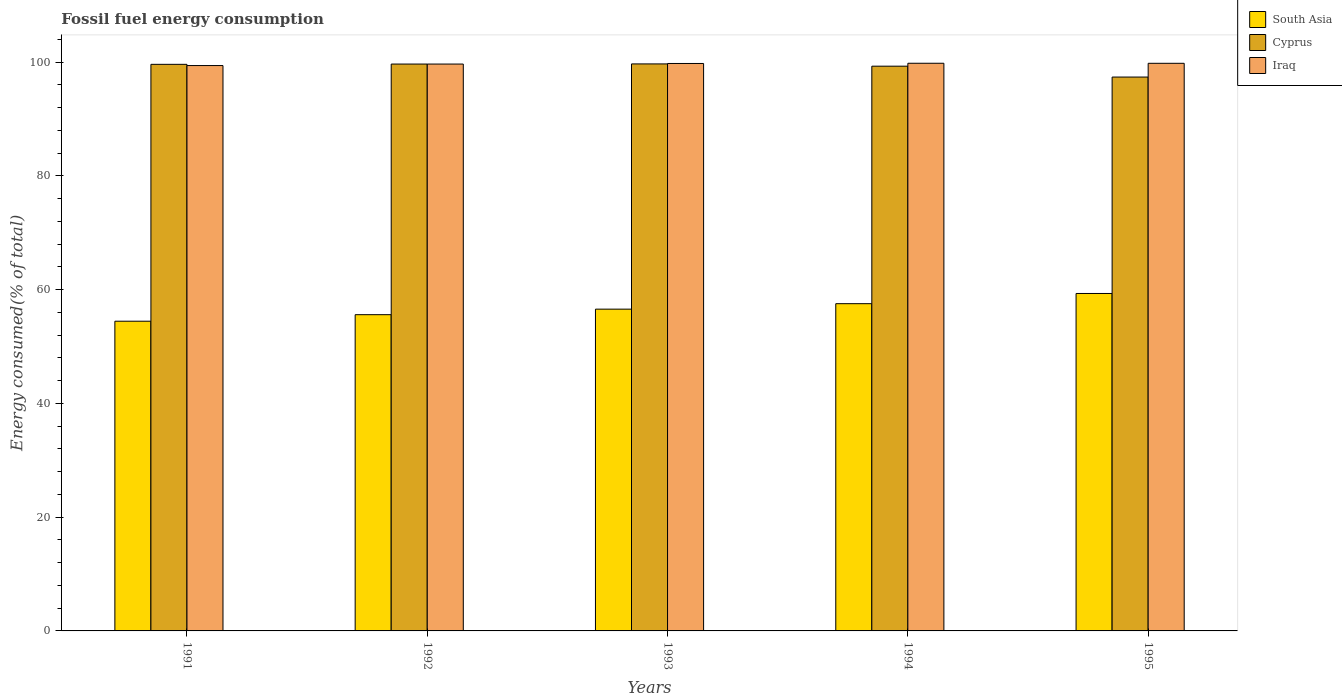How many different coloured bars are there?
Offer a terse response. 3. How many bars are there on the 2nd tick from the left?
Your response must be concise. 3. How many bars are there on the 5th tick from the right?
Offer a very short reply. 3. What is the label of the 5th group of bars from the left?
Provide a succinct answer. 1995. What is the percentage of energy consumed in Cyprus in 1994?
Give a very brief answer. 99.28. Across all years, what is the maximum percentage of energy consumed in Iraq?
Your answer should be compact. 99.79. Across all years, what is the minimum percentage of energy consumed in Iraq?
Give a very brief answer. 99.39. In which year was the percentage of energy consumed in Iraq maximum?
Give a very brief answer. 1994. In which year was the percentage of energy consumed in South Asia minimum?
Provide a succinct answer. 1991. What is the total percentage of energy consumed in Iraq in the graph?
Keep it short and to the point. 498.36. What is the difference between the percentage of energy consumed in Cyprus in 1991 and that in 1995?
Offer a very short reply. 2.24. What is the difference between the percentage of energy consumed in Cyprus in 1991 and the percentage of energy consumed in South Asia in 1994?
Ensure brevity in your answer.  42.08. What is the average percentage of energy consumed in South Asia per year?
Keep it short and to the point. 56.69. In the year 1994, what is the difference between the percentage of energy consumed in Iraq and percentage of energy consumed in South Asia?
Offer a terse response. 42.26. What is the ratio of the percentage of energy consumed in South Asia in 1992 to that in 1993?
Keep it short and to the point. 0.98. Is the difference between the percentage of energy consumed in Iraq in 1994 and 1995 greater than the difference between the percentage of energy consumed in South Asia in 1994 and 1995?
Ensure brevity in your answer.  Yes. What is the difference between the highest and the second highest percentage of energy consumed in South Asia?
Offer a terse response. 1.79. What is the difference between the highest and the lowest percentage of energy consumed in South Asia?
Give a very brief answer. 4.88. Is the sum of the percentage of energy consumed in Cyprus in 1993 and 1994 greater than the maximum percentage of energy consumed in Iraq across all years?
Offer a terse response. Yes. What does the 3rd bar from the left in 1991 represents?
Give a very brief answer. Iraq. What does the 2nd bar from the right in 1993 represents?
Ensure brevity in your answer.  Cyprus. How many bars are there?
Offer a very short reply. 15. What is the difference between two consecutive major ticks on the Y-axis?
Keep it short and to the point. 20. Are the values on the major ticks of Y-axis written in scientific E-notation?
Offer a terse response. No. Does the graph contain any zero values?
Your answer should be compact. No. Where does the legend appear in the graph?
Offer a terse response. Top right. What is the title of the graph?
Ensure brevity in your answer.  Fossil fuel energy consumption. What is the label or title of the X-axis?
Give a very brief answer. Years. What is the label or title of the Y-axis?
Offer a terse response. Energy consumed(% of total). What is the Energy consumed(% of total) in South Asia in 1991?
Keep it short and to the point. 54.44. What is the Energy consumed(% of total) of Cyprus in 1991?
Ensure brevity in your answer.  99.6. What is the Energy consumed(% of total) in Iraq in 1991?
Give a very brief answer. 99.39. What is the Energy consumed(% of total) in South Asia in 1992?
Provide a short and direct response. 55.59. What is the Energy consumed(% of total) of Cyprus in 1992?
Keep it short and to the point. 99.65. What is the Energy consumed(% of total) of Iraq in 1992?
Your answer should be compact. 99.65. What is the Energy consumed(% of total) of South Asia in 1993?
Provide a succinct answer. 56.56. What is the Energy consumed(% of total) of Cyprus in 1993?
Offer a very short reply. 99.68. What is the Energy consumed(% of total) in Iraq in 1993?
Ensure brevity in your answer.  99.75. What is the Energy consumed(% of total) of South Asia in 1994?
Keep it short and to the point. 57.53. What is the Energy consumed(% of total) of Cyprus in 1994?
Your answer should be compact. 99.28. What is the Energy consumed(% of total) of Iraq in 1994?
Provide a succinct answer. 99.79. What is the Energy consumed(% of total) of South Asia in 1995?
Keep it short and to the point. 59.32. What is the Energy consumed(% of total) of Cyprus in 1995?
Provide a short and direct response. 97.37. What is the Energy consumed(% of total) in Iraq in 1995?
Offer a very short reply. 99.78. Across all years, what is the maximum Energy consumed(% of total) in South Asia?
Provide a short and direct response. 59.32. Across all years, what is the maximum Energy consumed(% of total) in Cyprus?
Your response must be concise. 99.68. Across all years, what is the maximum Energy consumed(% of total) in Iraq?
Your response must be concise. 99.79. Across all years, what is the minimum Energy consumed(% of total) of South Asia?
Provide a succinct answer. 54.44. Across all years, what is the minimum Energy consumed(% of total) of Cyprus?
Ensure brevity in your answer.  97.37. Across all years, what is the minimum Energy consumed(% of total) in Iraq?
Offer a very short reply. 99.39. What is the total Energy consumed(% of total) in South Asia in the graph?
Your answer should be compact. 283.45. What is the total Energy consumed(% of total) in Cyprus in the graph?
Keep it short and to the point. 495.57. What is the total Energy consumed(% of total) in Iraq in the graph?
Offer a very short reply. 498.36. What is the difference between the Energy consumed(% of total) in South Asia in 1991 and that in 1992?
Keep it short and to the point. -1.15. What is the difference between the Energy consumed(% of total) of Cyprus in 1991 and that in 1992?
Make the answer very short. -0.05. What is the difference between the Energy consumed(% of total) of Iraq in 1991 and that in 1992?
Offer a terse response. -0.26. What is the difference between the Energy consumed(% of total) of South Asia in 1991 and that in 1993?
Give a very brief answer. -2.12. What is the difference between the Energy consumed(% of total) in Cyprus in 1991 and that in 1993?
Offer a terse response. -0.07. What is the difference between the Energy consumed(% of total) in Iraq in 1991 and that in 1993?
Ensure brevity in your answer.  -0.37. What is the difference between the Energy consumed(% of total) in South Asia in 1991 and that in 1994?
Keep it short and to the point. -3.08. What is the difference between the Energy consumed(% of total) in Cyprus in 1991 and that in 1994?
Ensure brevity in your answer.  0.33. What is the difference between the Energy consumed(% of total) of Iraq in 1991 and that in 1994?
Make the answer very short. -0.4. What is the difference between the Energy consumed(% of total) of South Asia in 1991 and that in 1995?
Provide a succinct answer. -4.88. What is the difference between the Energy consumed(% of total) in Cyprus in 1991 and that in 1995?
Your response must be concise. 2.24. What is the difference between the Energy consumed(% of total) in Iraq in 1991 and that in 1995?
Offer a terse response. -0.39. What is the difference between the Energy consumed(% of total) in South Asia in 1992 and that in 1993?
Your answer should be very brief. -0.97. What is the difference between the Energy consumed(% of total) of Cyprus in 1992 and that in 1993?
Provide a succinct answer. -0.03. What is the difference between the Energy consumed(% of total) in Iraq in 1992 and that in 1993?
Ensure brevity in your answer.  -0.1. What is the difference between the Energy consumed(% of total) in South Asia in 1992 and that in 1994?
Provide a short and direct response. -1.93. What is the difference between the Energy consumed(% of total) of Cyprus in 1992 and that in 1994?
Your answer should be very brief. 0.37. What is the difference between the Energy consumed(% of total) of Iraq in 1992 and that in 1994?
Make the answer very short. -0.14. What is the difference between the Energy consumed(% of total) of South Asia in 1992 and that in 1995?
Provide a succinct answer. -3.73. What is the difference between the Energy consumed(% of total) in Cyprus in 1992 and that in 1995?
Offer a terse response. 2.28. What is the difference between the Energy consumed(% of total) in Iraq in 1992 and that in 1995?
Give a very brief answer. -0.13. What is the difference between the Energy consumed(% of total) in South Asia in 1993 and that in 1994?
Provide a succinct answer. -0.96. What is the difference between the Energy consumed(% of total) in Cyprus in 1993 and that in 1994?
Give a very brief answer. 0.4. What is the difference between the Energy consumed(% of total) in Iraq in 1993 and that in 1994?
Your answer should be very brief. -0.04. What is the difference between the Energy consumed(% of total) of South Asia in 1993 and that in 1995?
Provide a succinct answer. -2.76. What is the difference between the Energy consumed(% of total) in Cyprus in 1993 and that in 1995?
Offer a very short reply. 2.31. What is the difference between the Energy consumed(% of total) of Iraq in 1993 and that in 1995?
Provide a succinct answer. -0.03. What is the difference between the Energy consumed(% of total) in South Asia in 1994 and that in 1995?
Your response must be concise. -1.79. What is the difference between the Energy consumed(% of total) in Cyprus in 1994 and that in 1995?
Offer a very short reply. 1.91. What is the difference between the Energy consumed(% of total) of Iraq in 1994 and that in 1995?
Provide a succinct answer. 0.01. What is the difference between the Energy consumed(% of total) in South Asia in 1991 and the Energy consumed(% of total) in Cyprus in 1992?
Your answer should be compact. -45.21. What is the difference between the Energy consumed(% of total) of South Asia in 1991 and the Energy consumed(% of total) of Iraq in 1992?
Your answer should be very brief. -45.21. What is the difference between the Energy consumed(% of total) in Cyprus in 1991 and the Energy consumed(% of total) in Iraq in 1992?
Provide a short and direct response. -0.05. What is the difference between the Energy consumed(% of total) of South Asia in 1991 and the Energy consumed(% of total) of Cyprus in 1993?
Keep it short and to the point. -45.23. What is the difference between the Energy consumed(% of total) in South Asia in 1991 and the Energy consumed(% of total) in Iraq in 1993?
Ensure brevity in your answer.  -45.31. What is the difference between the Energy consumed(% of total) of Cyprus in 1991 and the Energy consumed(% of total) of Iraq in 1993?
Ensure brevity in your answer.  -0.15. What is the difference between the Energy consumed(% of total) of South Asia in 1991 and the Energy consumed(% of total) of Cyprus in 1994?
Keep it short and to the point. -44.83. What is the difference between the Energy consumed(% of total) of South Asia in 1991 and the Energy consumed(% of total) of Iraq in 1994?
Provide a short and direct response. -45.35. What is the difference between the Energy consumed(% of total) of Cyprus in 1991 and the Energy consumed(% of total) of Iraq in 1994?
Make the answer very short. -0.19. What is the difference between the Energy consumed(% of total) in South Asia in 1991 and the Energy consumed(% of total) in Cyprus in 1995?
Keep it short and to the point. -42.92. What is the difference between the Energy consumed(% of total) of South Asia in 1991 and the Energy consumed(% of total) of Iraq in 1995?
Make the answer very short. -45.34. What is the difference between the Energy consumed(% of total) of Cyprus in 1991 and the Energy consumed(% of total) of Iraq in 1995?
Keep it short and to the point. -0.18. What is the difference between the Energy consumed(% of total) of South Asia in 1992 and the Energy consumed(% of total) of Cyprus in 1993?
Provide a succinct answer. -44.08. What is the difference between the Energy consumed(% of total) in South Asia in 1992 and the Energy consumed(% of total) in Iraq in 1993?
Keep it short and to the point. -44.16. What is the difference between the Energy consumed(% of total) of Cyprus in 1992 and the Energy consumed(% of total) of Iraq in 1993?
Ensure brevity in your answer.  -0.1. What is the difference between the Energy consumed(% of total) in South Asia in 1992 and the Energy consumed(% of total) in Cyprus in 1994?
Your answer should be very brief. -43.69. What is the difference between the Energy consumed(% of total) of South Asia in 1992 and the Energy consumed(% of total) of Iraq in 1994?
Provide a short and direct response. -44.2. What is the difference between the Energy consumed(% of total) of Cyprus in 1992 and the Energy consumed(% of total) of Iraq in 1994?
Ensure brevity in your answer.  -0.14. What is the difference between the Energy consumed(% of total) in South Asia in 1992 and the Energy consumed(% of total) in Cyprus in 1995?
Keep it short and to the point. -41.77. What is the difference between the Energy consumed(% of total) of South Asia in 1992 and the Energy consumed(% of total) of Iraq in 1995?
Offer a terse response. -44.19. What is the difference between the Energy consumed(% of total) of Cyprus in 1992 and the Energy consumed(% of total) of Iraq in 1995?
Offer a terse response. -0.13. What is the difference between the Energy consumed(% of total) of South Asia in 1993 and the Energy consumed(% of total) of Cyprus in 1994?
Your answer should be compact. -42.71. What is the difference between the Energy consumed(% of total) in South Asia in 1993 and the Energy consumed(% of total) in Iraq in 1994?
Your answer should be very brief. -43.23. What is the difference between the Energy consumed(% of total) in Cyprus in 1993 and the Energy consumed(% of total) in Iraq in 1994?
Keep it short and to the point. -0.12. What is the difference between the Energy consumed(% of total) in South Asia in 1993 and the Energy consumed(% of total) in Cyprus in 1995?
Your answer should be very brief. -40.8. What is the difference between the Energy consumed(% of total) in South Asia in 1993 and the Energy consumed(% of total) in Iraq in 1995?
Provide a short and direct response. -43.22. What is the difference between the Energy consumed(% of total) of Cyprus in 1993 and the Energy consumed(% of total) of Iraq in 1995?
Make the answer very short. -0.11. What is the difference between the Energy consumed(% of total) of South Asia in 1994 and the Energy consumed(% of total) of Cyprus in 1995?
Your answer should be very brief. -39.84. What is the difference between the Energy consumed(% of total) of South Asia in 1994 and the Energy consumed(% of total) of Iraq in 1995?
Keep it short and to the point. -42.26. What is the difference between the Energy consumed(% of total) of Cyprus in 1994 and the Energy consumed(% of total) of Iraq in 1995?
Offer a very short reply. -0.5. What is the average Energy consumed(% of total) in South Asia per year?
Give a very brief answer. 56.69. What is the average Energy consumed(% of total) in Cyprus per year?
Your answer should be compact. 99.11. What is the average Energy consumed(% of total) in Iraq per year?
Your answer should be very brief. 99.67. In the year 1991, what is the difference between the Energy consumed(% of total) in South Asia and Energy consumed(% of total) in Cyprus?
Your response must be concise. -45.16. In the year 1991, what is the difference between the Energy consumed(% of total) of South Asia and Energy consumed(% of total) of Iraq?
Keep it short and to the point. -44.94. In the year 1991, what is the difference between the Energy consumed(% of total) of Cyprus and Energy consumed(% of total) of Iraq?
Your answer should be very brief. 0.21. In the year 1992, what is the difference between the Energy consumed(% of total) of South Asia and Energy consumed(% of total) of Cyprus?
Provide a succinct answer. -44.06. In the year 1992, what is the difference between the Energy consumed(% of total) in South Asia and Energy consumed(% of total) in Iraq?
Provide a succinct answer. -44.06. In the year 1992, what is the difference between the Energy consumed(% of total) of Cyprus and Energy consumed(% of total) of Iraq?
Your answer should be very brief. -0. In the year 1993, what is the difference between the Energy consumed(% of total) in South Asia and Energy consumed(% of total) in Cyprus?
Give a very brief answer. -43.11. In the year 1993, what is the difference between the Energy consumed(% of total) in South Asia and Energy consumed(% of total) in Iraq?
Ensure brevity in your answer.  -43.19. In the year 1993, what is the difference between the Energy consumed(% of total) in Cyprus and Energy consumed(% of total) in Iraq?
Provide a succinct answer. -0.08. In the year 1994, what is the difference between the Energy consumed(% of total) of South Asia and Energy consumed(% of total) of Cyprus?
Keep it short and to the point. -41.75. In the year 1994, what is the difference between the Energy consumed(% of total) in South Asia and Energy consumed(% of total) in Iraq?
Offer a very short reply. -42.26. In the year 1994, what is the difference between the Energy consumed(% of total) of Cyprus and Energy consumed(% of total) of Iraq?
Your answer should be very brief. -0.51. In the year 1995, what is the difference between the Energy consumed(% of total) of South Asia and Energy consumed(% of total) of Cyprus?
Give a very brief answer. -38.05. In the year 1995, what is the difference between the Energy consumed(% of total) of South Asia and Energy consumed(% of total) of Iraq?
Offer a terse response. -40.46. In the year 1995, what is the difference between the Energy consumed(% of total) of Cyprus and Energy consumed(% of total) of Iraq?
Provide a succinct answer. -2.42. What is the ratio of the Energy consumed(% of total) of South Asia in 1991 to that in 1992?
Your response must be concise. 0.98. What is the ratio of the Energy consumed(% of total) in Cyprus in 1991 to that in 1992?
Your response must be concise. 1. What is the ratio of the Energy consumed(% of total) of South Asia in 1991 to that in 1993?
Make the answer very short. 0.96. What is the ratio of the Energy consumed(% of total) in South Asia in 1991 to that in 1994?
Provide a short and direct response. 0.95. What is the ratio of the Energy consumed(% of total) of Cyprus in 1991 to that in 1994?
Your answer should be compact. 1. What is the ratio of the Energy consumed(% of total) in Iraq in 1991 to that in 1994?
Ensure brevity in your answer.  1. What is the ratio of the Energy consumed(% of total) of South Asia in 1991 to that in 1995?
Keep it short and to the point. 0.92. What is the ratio of the Energy consumed(% of total) of Cyprus in 1991 to that in 1995?
Your answer should be very brief. 1.02. What is the ratio of the Energy consumed(% of total) in Iraq in 1991 to that in 1995?
Ensure brevity in your answer.  1. What is the ratio of the Energy consumed(% of total) in South Asia in 1992 to that in 1993?
Your response must be concise. 0.98. What is the ratio of the Energy consumed(% of total) in Iraq in 1992 to that in 1993?
Ensure brevity in your answer.  1. What is the ratio of the Energy consumed(% of total) in South Asia in 1992 to that in 1994?
Keep it short and to the point. 0.97. What is the ratio of the Energy consumed(% of total) of Iraq in 1992 to that in 1994?
Give a very brief answer. 1. What is the ratio of the Energy consumed(% of total) in South Asia in 1992 to that in 1995?
Keep it short and to the point. 0.94. What is the ratio of the Energy consumed(% of total) in Cyprus in 1992 to that in 1995?
Your answer should be very brief. 1.02. What is the ratio of the Energy consumed(% of total) of South Asia in 1993 to that in 1994?
Offer a very short reply. 0.98. What is the ratio of the Energy consumed(% of total) of Iraq in 1993 to that in 1994?
Make the answer very short. 1. What is the ratio of the Energy consumed(% of total) of South Asia in 1993 to that in 1995?
Your response must be concise. 0.95. What is the ratio of the Energy consumed(% of total) in Cyprus in 1993 to that in 1995?
Offer a very short reply. 1.02. What is the ratio of the Energy consumed(% of total) in South Asia in 1994 to that in 1995?
Keep it short and to the point. 0.97. What is the ratio of the Energy consumed(% of total) in Cyprus in 1994 to that in 1995?
Keep it short and to the point. 1.02. What is the difference between the highest and the second highest Energy consumed(% of total) of South Asia?
Ensure brevity in your answer.  1.79. What is the difference between the highest and the second highest Energy consumed(% of total) in Cyprus?
Offer a very short reply. 0.03. What is the difference between the highest and the second highest Energy consumed(% of total) of Iraq?
Your response must be concise. 0.01. What is the difference between the highest and the lowest Energy consumed(% of total) in South Asia?
Your response must be concise. 4.88. What is the difference between the highest and the lowest Energy consumed(% of total) in Cyprus?
Offer a terse response. 2.31. What is the difference between the highest and the lowest Energy consumed(% of total) of Iraq?
Offer a very short reply. 0.4. 